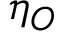<formula> <loc_0><loc_0><loc_500><loc_500>\eta _ { O }</formula> 